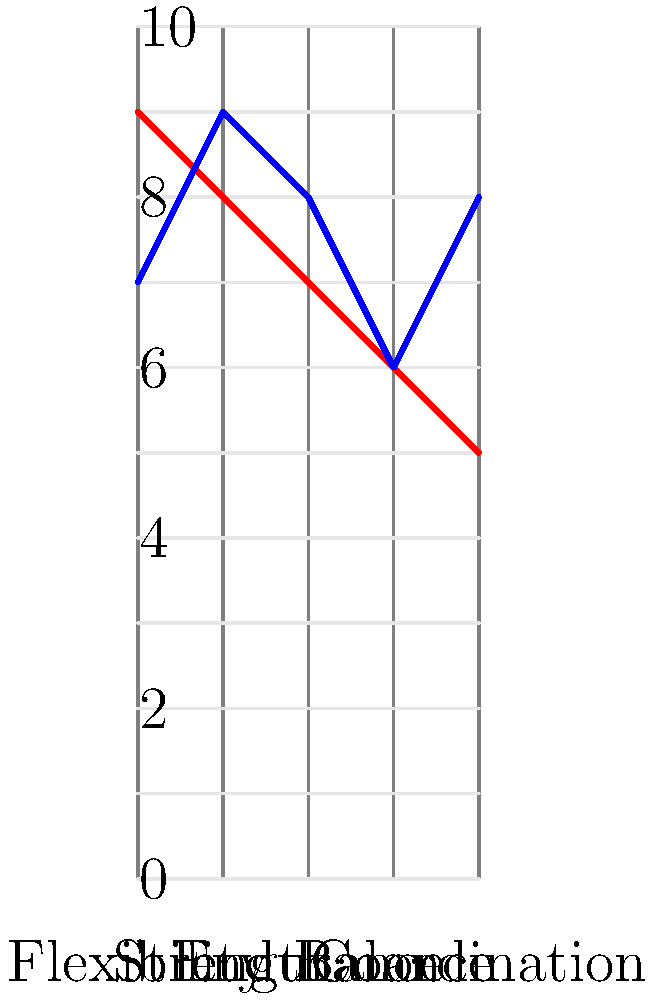Based on the diagram comparing the physical demands of ballet and hip-hop dance moves, which aspect shows the most significant difference between the two dance forms? To answer this question, we need to analyze the diagram and compare the values for each aspect between ballet and hip-hop:

1. Flexibility: Ballet (9) vs Hip-hop (7) - Difference of 2
2. Strength: Ballet (8) vs Hip-hop (9) - Difference of 1
3. Endurance: Ballet (7) vs Hip-hop (8) - Difference of 1
4. Balance: Ballet (6) vs Hip-hop (6) - No difference
5. Coordination: Ballet (5) vs Hip-hop (8) - Difference of 3

The aspect with the most significant difference is the one with the largest gap between the two dance forms. In this case, it's Coordination, with a difference of 3 points (5 for ballet vs 8 for hip-hop).

This difference highlights that while ballet requires high levels of coordination, hip-hop dancing demands even more complex coordination skills due to its often rapid and intricate movements.
Answer: Coordination 